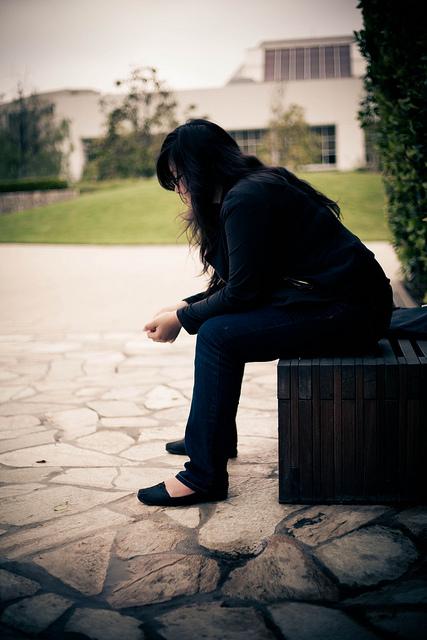What is she sitting on?
Concise answer only. Bench. What type of shoes is she wearing?
Short answer required. Flats. Is the woman waiting for someone?
Keep it brief. Yes. 